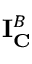Convert formula to latex. <formula><loc_0><loc_0><loc_500><loc_500>I _ { C } ^ { B }</formula> 